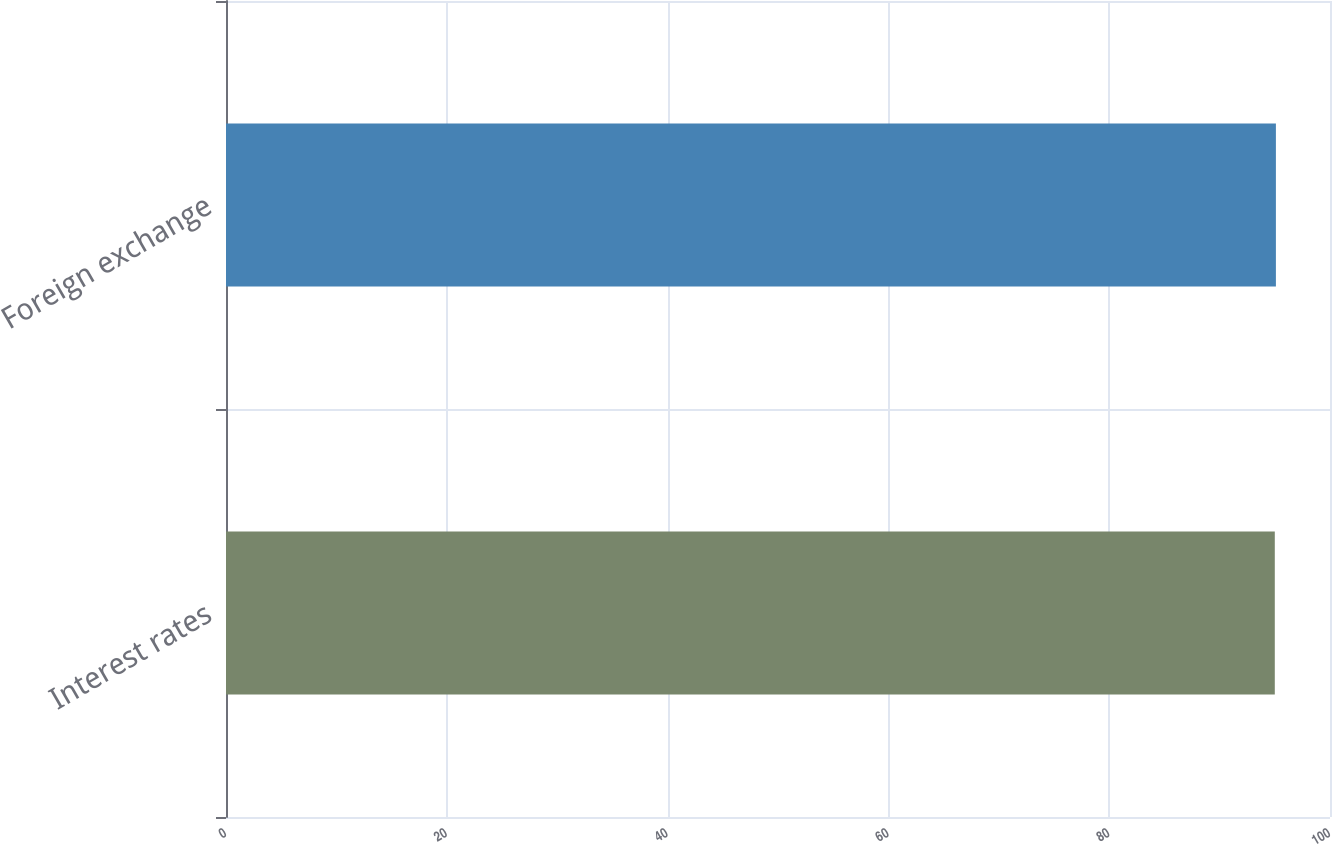<chart> <loc_0><loc_0><loc_500><loc_500><bar_chart><fcel>Interest rates<fcel>Foreign exchange<nl><fcel>95<fcel>95.1<nl></chart> 